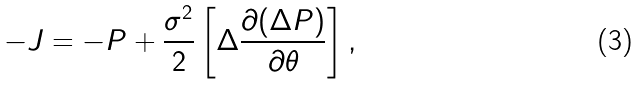<formula> <loc_0><loc_0><loc_500><loc_500>- J = - P + \frac { \sigma ^ { 2 } } { 2 } \left [ \Delta \frac { \partial ( \Delta P ) } { \partial \theta } \right ] ,</formula> 